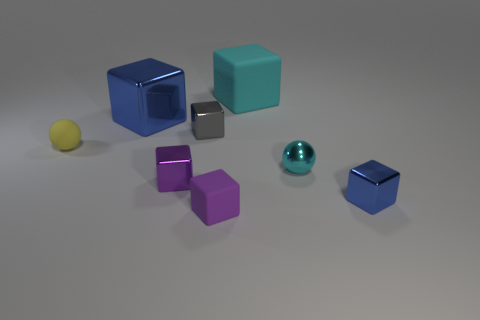What number of small cyan shiny objects have the same shape as the big blue metal object?
Keep it short and to the point. 0. What shape is the tiny blue object?
Your response must be concise. Cube. There is a cyan thing that is behind the ball on the left side of the big blue metal thing; what size is it?
Make the answer very short. Large. What number of objects are small gray shiny objects or small red objects?
Offer a terse response. 1. Do the purple rubber object and the large matte thing have the same shape?
Provide a succinct answer. Yes. Is there a small cyan ball made of the same material as the large blue object?
Provide a succinct answer. Yes. Is there a small yellow object behind the big blue object on the left side of the purple metal block?
Provide a short and direct response. No. Does the blue cube in front of the purple metallic object have the same size as the big cyan matte cube?
Ensure brevity in your answer.  No. The cyan shiny sphere has what size?
Keep it short and to the point. Small. Are there any objects of the same color as the rubber sphere?
Keep it short and to the point. No. 